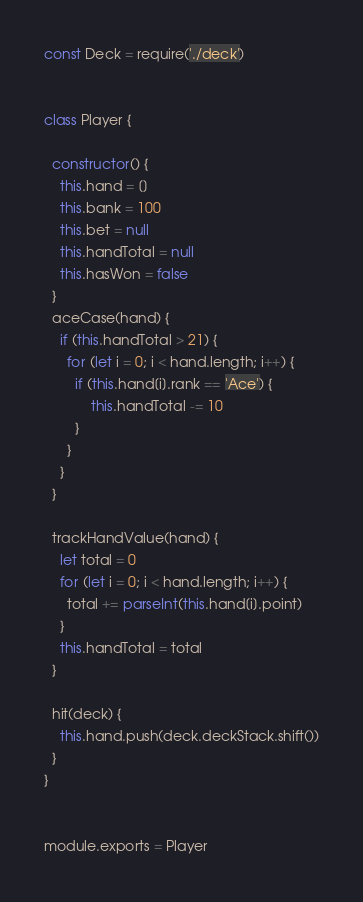<code> <loc_0><loc_0><loc_500><loc_500><_JavaScript_>const Deck = require('./deck')


class Player {

  constructor() {
    this.hand = []
    this.bank = 100
    this.bet = null
    this.handTotal = null
    this.hasWon = false
  }
  aceCase(hand) {
    if (this.handTotal > 21) {
      for (let i = 0; i < hand.length; i++) {
        if (this.hand[i].rank == 'Ace') {
            this.handTotal -= 10
        }
      }
    }
  }

  trackHandValue(hand) {
    let total = 0
    for (let i = 0; i < hand.length; i++) {
      total += parseInt(this.hand[i].point)
    }
    this.handTotal = total
  }

  hit(deck) {
    this.hand.push(deck.deckStack.shift())
  }
}


module.exports = Player
</code> 